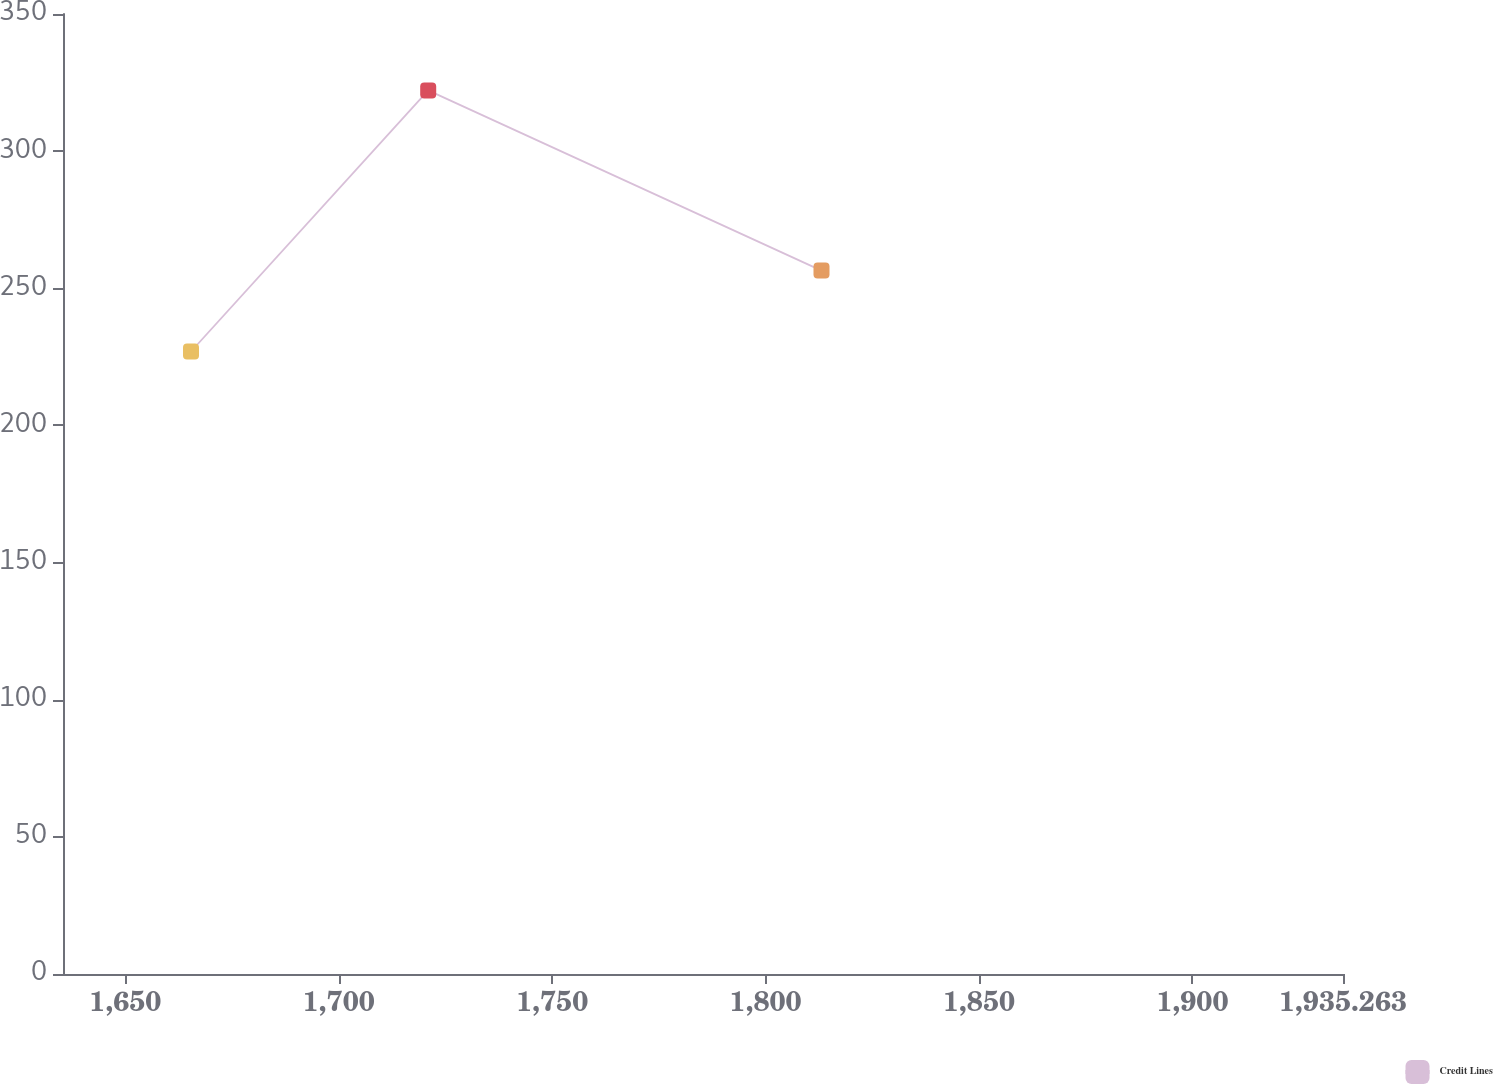Convert chart. <chart><loc_0><loc_0><loc_500><loc_500><line_chart><ecel><fcel>Credit Lines<nl><fcel>1665.38<fcel>226.96<nl><fcel>1720.95<fcel>322.14<nl><fcel>1813.09<fcel>256.46<nl><fcel>1935.34<fcel>118.23<nl><fcel>1965.25<fcel>276.85<nl></chart> 